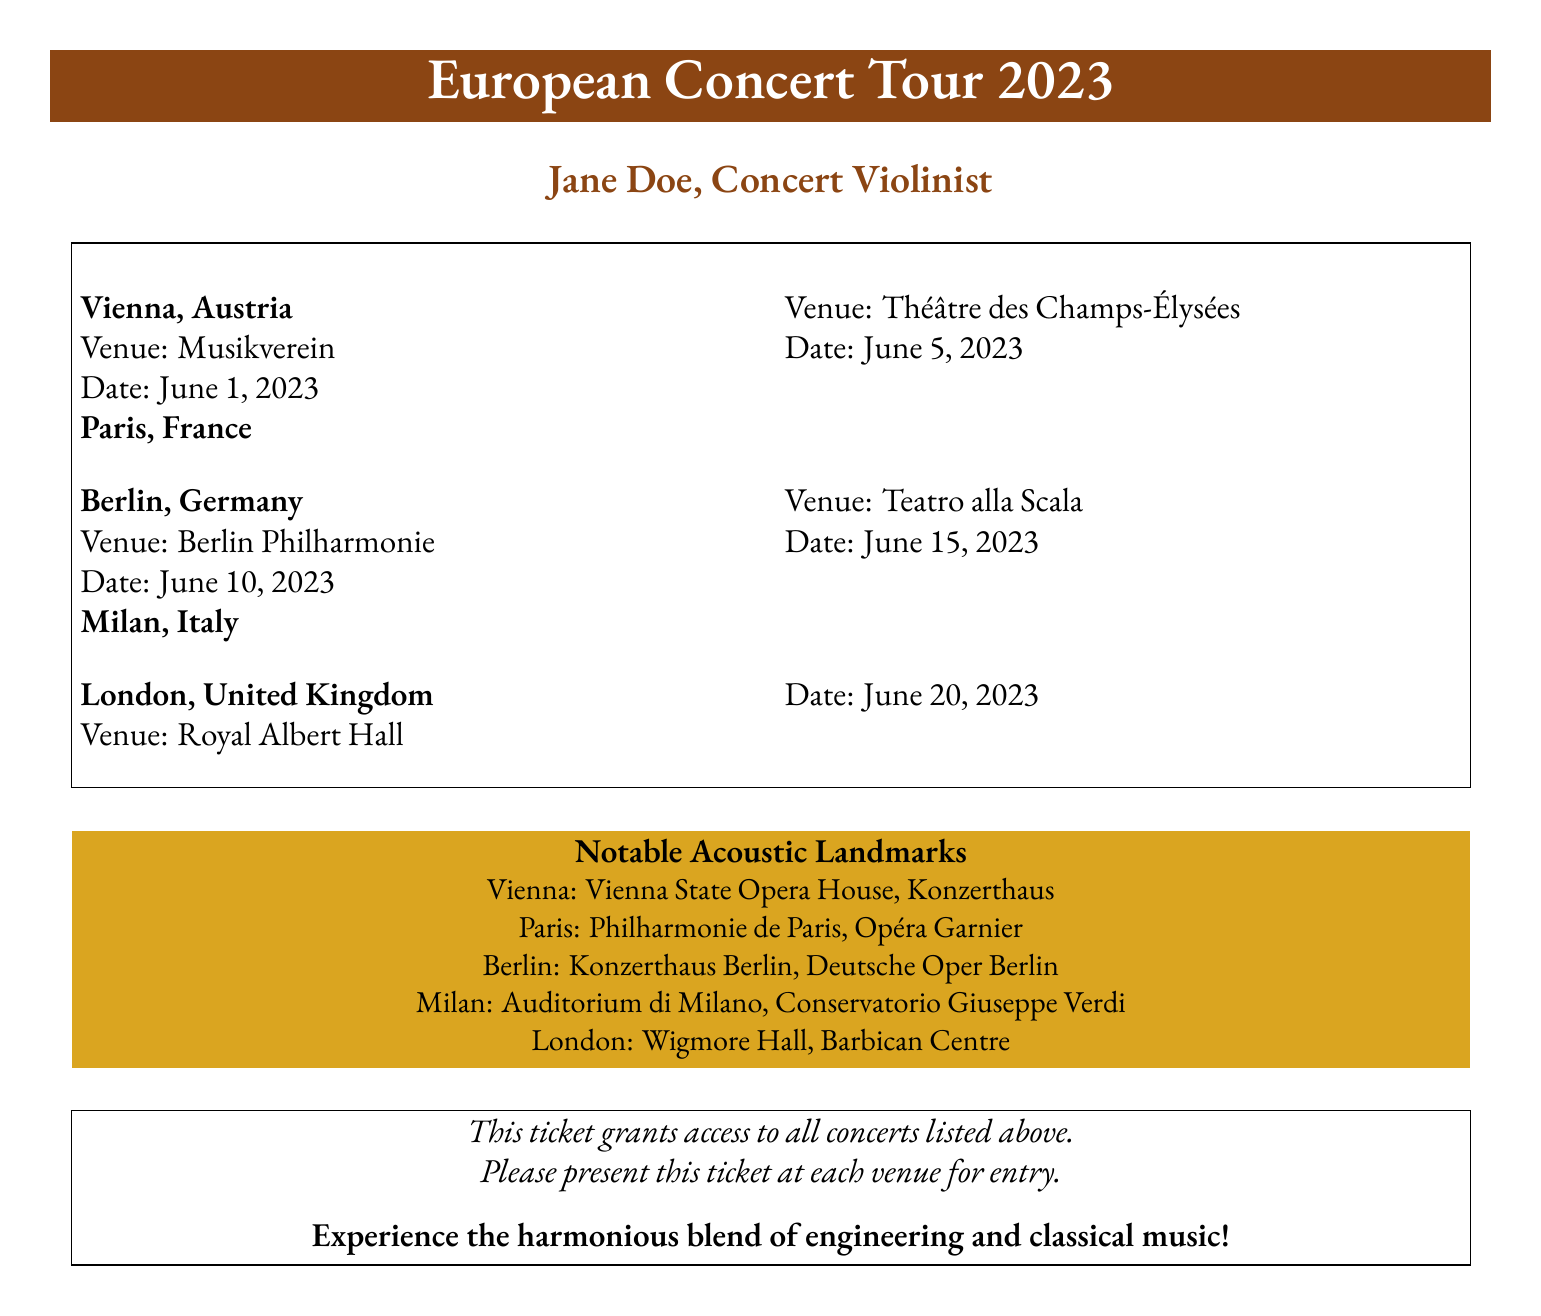What is the first concert date? The first concert date listed in the document is for Vienna on June 1, 2023.
Answer: June 1, 2023 Which venue is located in Berlin? The document specifies that the venue in Berlin is the Berlin Philharmonie.
Answer: Berlin Philharmonie How many cities are included in the concert itinerary? The document lists five cities in total that are included in the concert itinerary.
Answer: Five What is the purpose of this ticket? The ticket grants access to all concerts listed in the document.
Answer: Access to all concerts Which notable acoustic landmark is in Paris? The document mentions the Philharmonie de Paris as a notable acoustic landmark in Paris.
Answer: Philharmonie de Paris What venue is scheduled for June 20, 2023? The venue scheduled for June 20, 2023, is the Royal Albert Hall in London.
Answer: Royal Albert Hall What type of music event is featured in this document? The document indicates that the event is a concert tour featuring classical music performances.
Answer: Concert tour What color is used for the ticket's heading? The heading of the ticket uses a brown color identified as violin brown.
Answer: Violin brown 